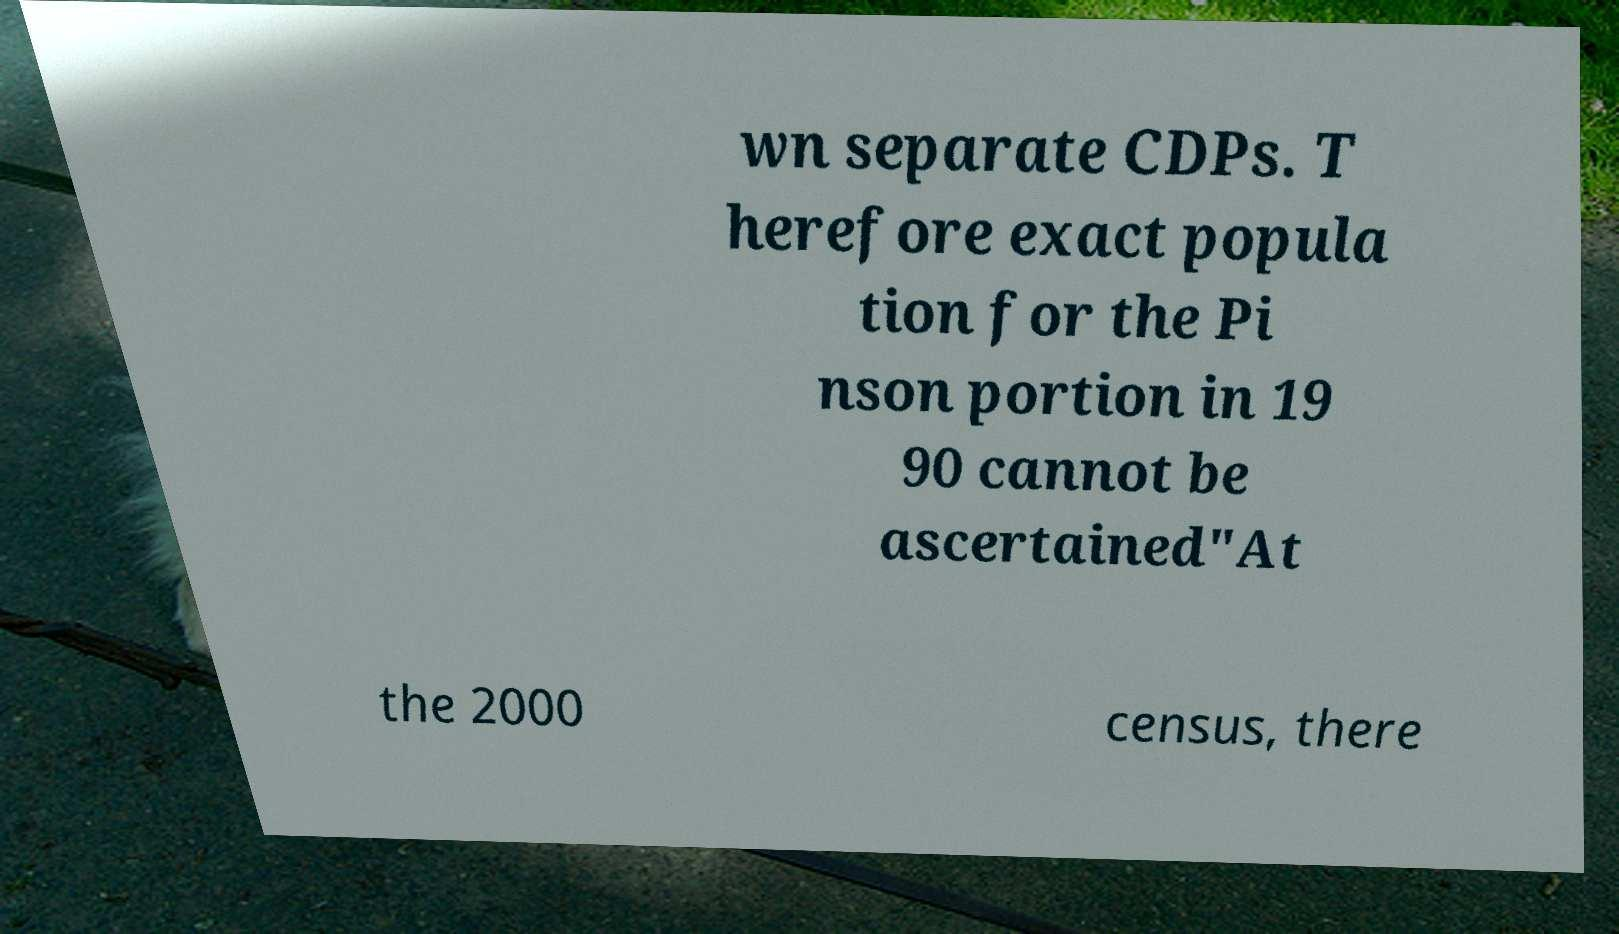Can you read and provide the text displayed in the image?This photo seems to have some interesting text. Can you extract and type it out for me? wn separate CDPs. T herefore exact popula tion for the Pi nson portion in 19 90 cannot be ascertained"At the 2000 census, there 